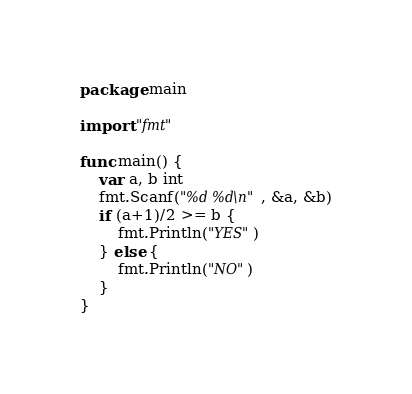<code> <loc_0><loc_0><loc_500><loc_500><_Go_>package main

import "fmt"

func main() {
	var a, b int
	fmt.Scanf("%d %d\n", &a, &b)
	if (a+1)/2 >= b {
		fmt.Println("YES")
	} else {
		fmt.Println("NO")
	}
}
</code> 